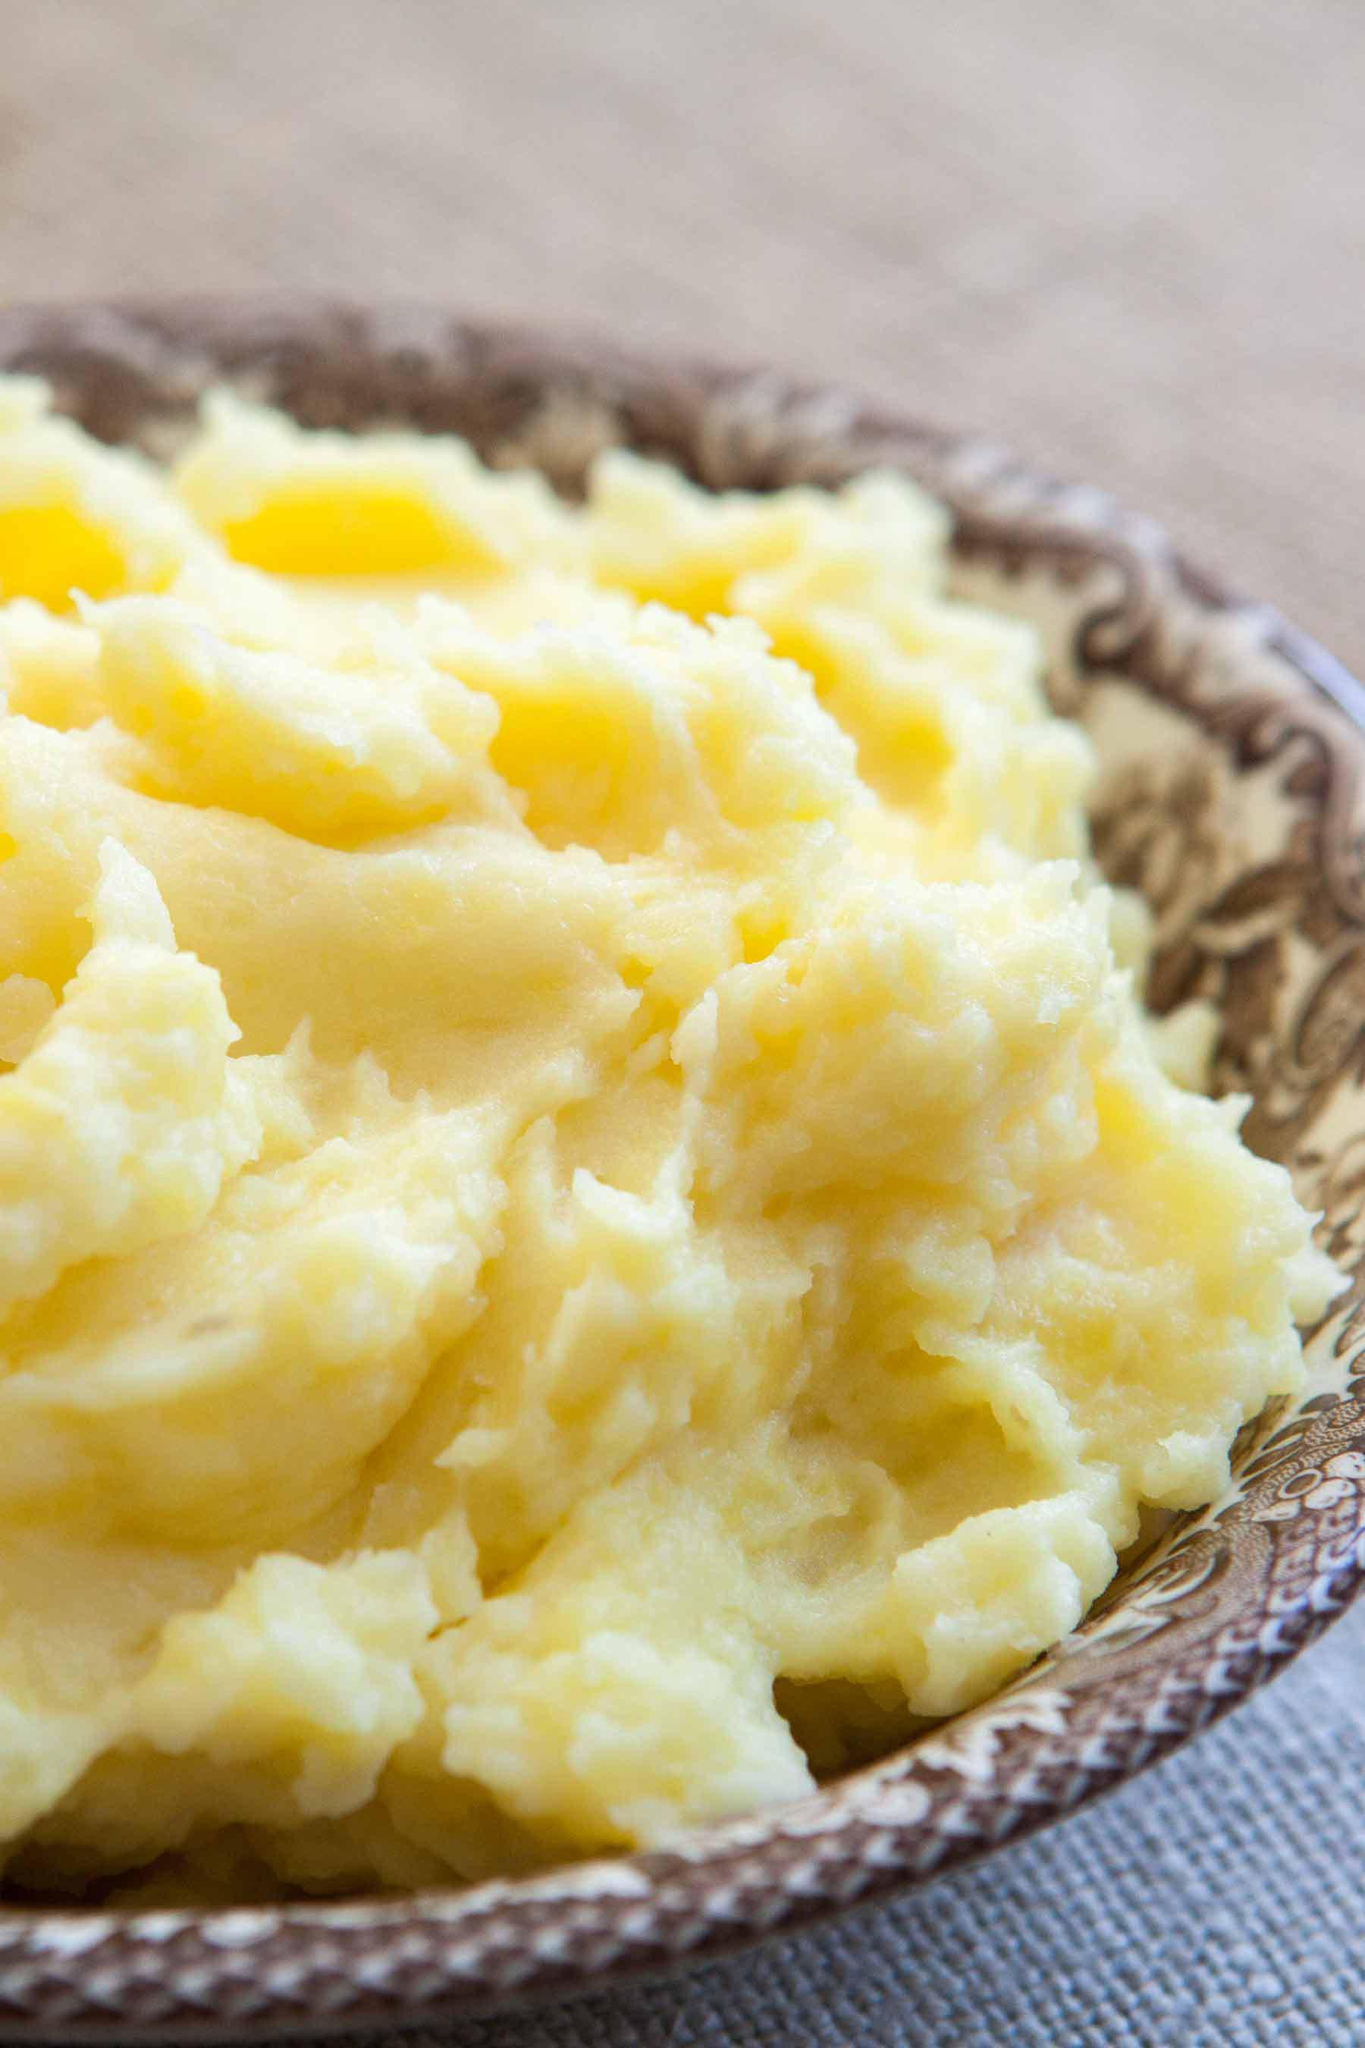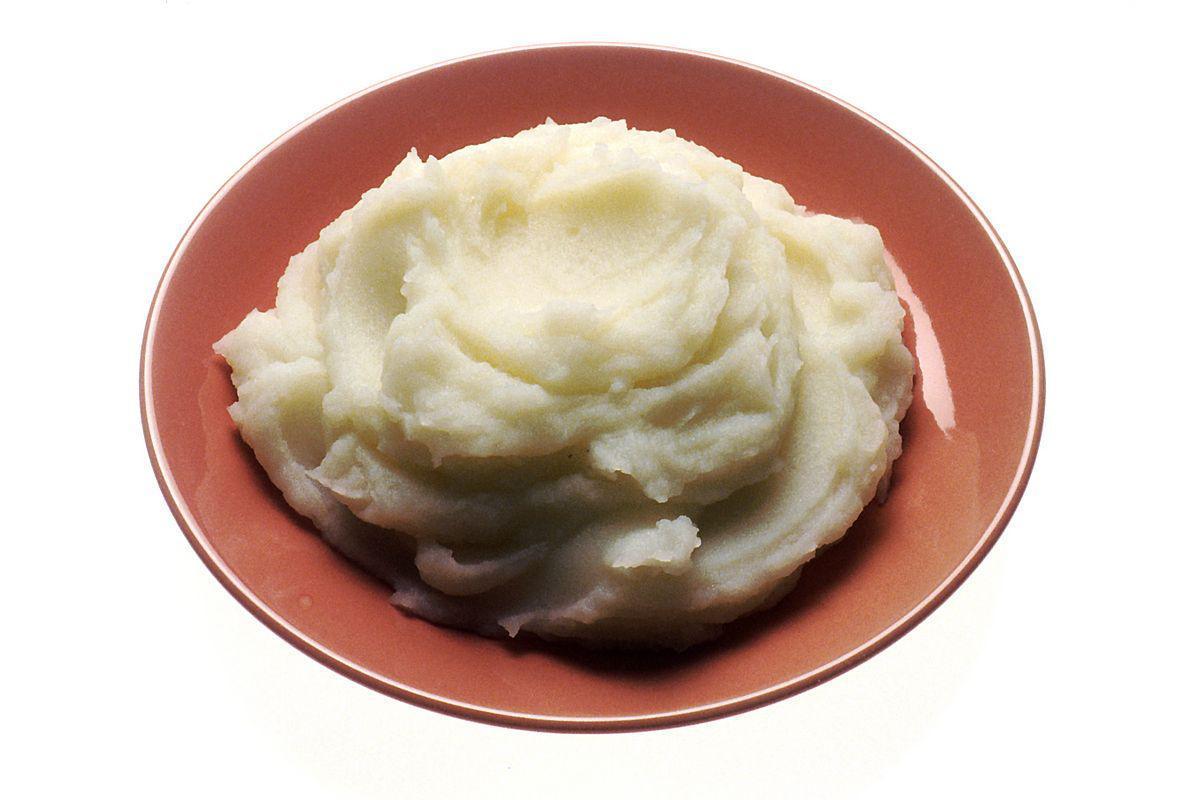The first image is the image on the left, the second image is the image on the right. Given the left and right images, does the statement "the mashed potato on the right image is on a white bowl." hold true? Answer yes or no. No. 